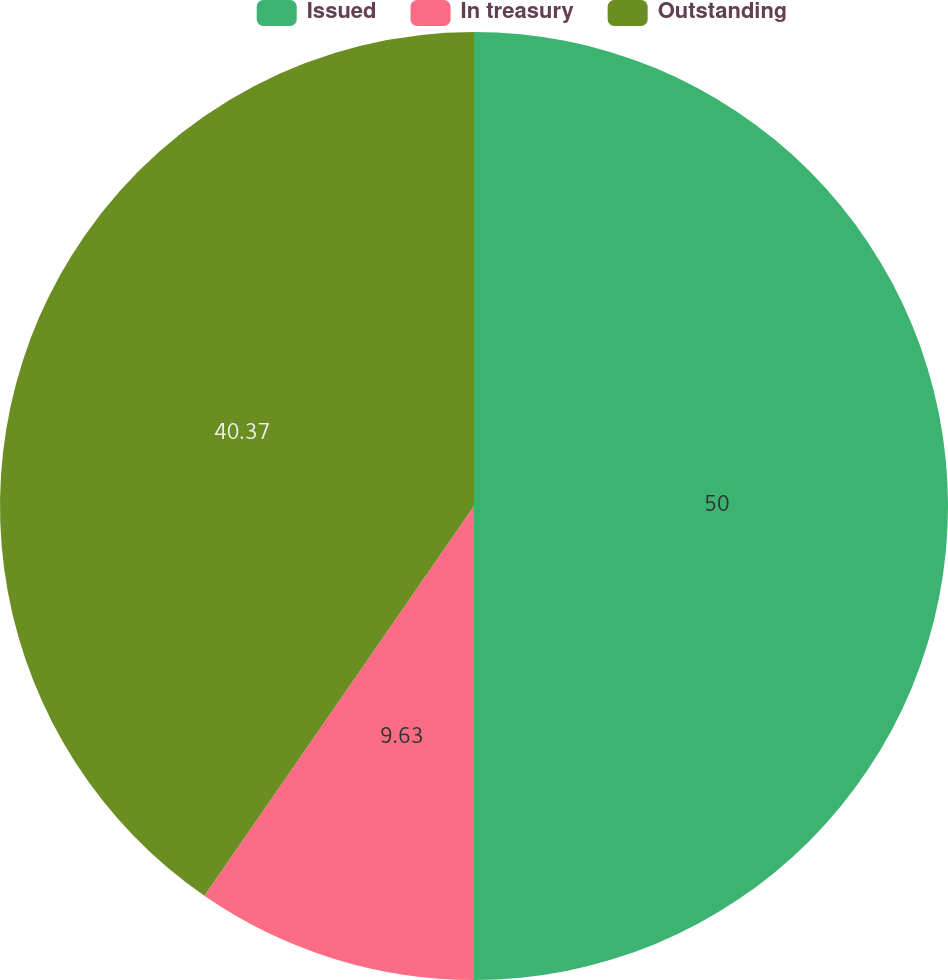Convert chart to OTSL. <chart><loc_0><loc_0><loc_500><loc_500><pie_chart><fcel>Issued<fcel>In treasury<fcel>Outstanding<nl><fcel>50.0%<fcel>9.63%<fcel>40.37%<nl></chart> 